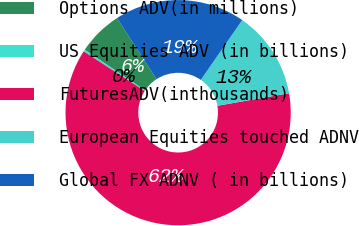<chart> <loc_0><loc_0><loc_500><loc_500><pie_chart><fcel>Options ADV(in millions)<fcel>US Equities ADV (in billions)<fcel>FuturesADV(inthousands)<fcel>European Equities touched ADNV<fcel>Global FX ADNV ( in billions)<nl><fcel>6.44%<fcel>0.27%<fcel>61.92%<fcel>12.6%<fcel>18.77%<nl></chart> 